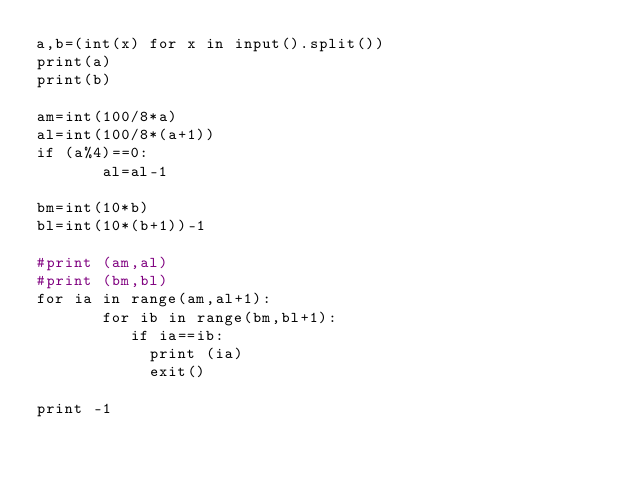<code> <loc_0><loc_0><loc_500><loc_500><_Python_>a,b=(int(x) for x in input().split())
print(a)
print(b)

am=int(100/8*a)
al=int(100/8*(a+1))
if (a%4)==0:
       al=al-1

bm=int(10*b)
bl=int(10*(b+1))-1

#print (am,al)
#print (bm,bl)
for ia in range(am,al+1):
       for ib in range(bm,bl+1):
       		if ia==ib:
       			print (ia)
       			exit()
      
print -1</code> 